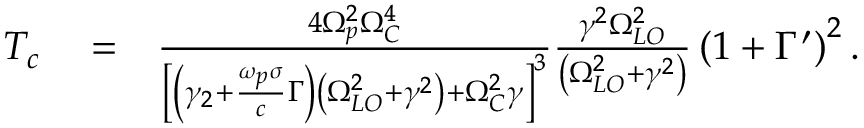Convert formula to latex. <formula><loc_0><loc_0><loc_500><loc_500>\begin{array} { r l r } { T _ { c } } & = } & { \frac { 4 \Omega _ { p } ^ { 2 } \Omega _ { C } ^ { 4 } } { \left [ \left ( \gamma _ { 2 } + \frac { \omega _ { p } \sigma } { c } \Gamma \right ) \left ( \Omega _ { L O } ^ { 2 } + \gamma ^ { 2 } \right ) + \Omega _ { C } ^ { 2 } \gamma \right ] ^ { 3 } } \frac { \gamma ^ { 2 } \Omega _ { L O } ^ { 2 } } { \left ( \Omega _ { L O } ^ { 2 } + \gamma ^ { 2 } \right ) } \left ( 1 + \Gamma ^ { \prime } \right ) ^ { 2 } . } \end{array}</formula> 